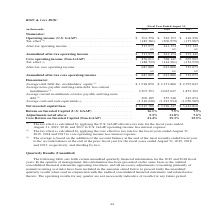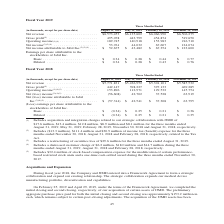From Jabil Circuit's financial document, Which months ended quarters does the table show information for Net revenue? The document contains multiple relevant values: August 31, 2018, May 31, 2018, February 28, 2018, November 30, 2017. From the document: "(in thousands, except for per share data) August 31, 2018 May 31, 2018 February 28, 2018 November 30, 2017 sands, except for per share data) August 31..." Also, How much was the income tax (benefit) expense for the three months ended November 30, 2018, August 31, 2018 and February 28, 2018, respectively? The document contains multiple relevant values: ($13.3 million), $111.4 million, $30.9 million. From the document: "2018, respectively. (2) Includes ($13.3 million), $111.4 million and $30.9 million of income tax (benefit) expense for the three months ended November..." Also, What were the distressed customer charges for  the three months ended August 31, 2019, August 31, 2018 and February 28, 2018, respectively? The document contains multiple relevant values: $6.2 million, $18.0 million, $14.7 million. From the document: "2019. (4) Includes a distressed customer charge of $6.2 million, $18.0 million and $14.7 million during the three months ended August 31, 2019, August..." Also, can you calculate: What was the change in gross profit between May 2018 and August 2018? Based on the calculation: 442,147-398,227, the result is 43920 (in thousands). This is based on the information: ",436,952 $5,301,101 $5,585,532 Gross profit (4) . 442,147 398,227 397,133 469,285 Operating income (1)(4)(5) . 153,896 112,971 129,532 145,754 Net (loss) inc $5,301,101 $5,585,532 Gross profit (4) . 4..." The key data points involved are: 398,227, 442,147. Also, How many quarters did operating income exceed $150,000 thousand? Based on the analysis, there are 1 instances. The counting process: August 31, 2018. Also, can you calculate: What was the percentage change in net revenue between the three months ended November 30, 2017 and February 28, 2018? To answer this question, I need to perform calculations using the financial data. The calculation is: ($5,301,101-$5,585,532)/$5,585,532, which equals -5.09 (percentage). This is based on the information: "Net revenue . $5,771,831 $5,436,952 $5,301,101 $5,585,532 Gross profit (4) . 442,147 398,227 397,133 469,285 Operating income (1)(4)(5) . 153,896 Net revenue . $5,771,831 $5,436,952 $5,301,101 $5,585,..." The key data points involved are: 5,301,101, 5,585,532. 